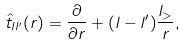Convert formula to latex. <formula><loc_0><loc_0><loc_500><loc_500>\hat { t } _ { l l ^ { \prime } } ( r ) = \frac { \partial } { \partial r } + ( l - l ^ { \prime } ) \frac { l _ { > } } { r } ,</formula> 